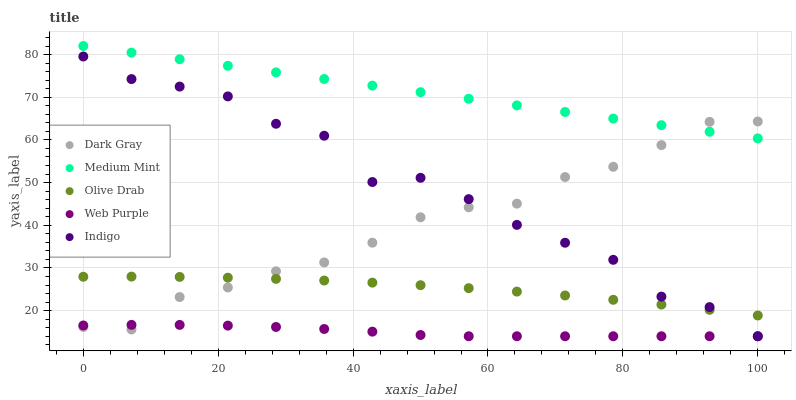Does Web Purple have the minimum area under the curve?
Answer yes or no. Yes. Does Medium Mint have the maximum area under the curve?
Answer yes or no. Yes. Does Medium Mint have the minimum area under the curve?
Answer yes or no. No. Does Web Purple have the maximum area under the curve?
Answer yes or no. No. Is Medium Mint the smoothest?
Answer yes or no. Yes. Is Indigo the roughest?
Answer yes or no. Yes. Is Web Purple the smoothest?
Answer yes or no. No. Is Web Purple the roughest?
Answer yes or no. No. Does Web Purple have the lowest value?
Answer yes or no. Yes. Does Medium Mint have the lowest value?
Answer yes or no. No. Does Medium Mint have the highest value?
Answer yes or no. Yes. Does Web Purple have the highest value?
Answer yes or no. No. Is Web Purple less than Medium Mint?
Answer yes or no. Yes. Is Olive Drab greater than Web Purple?
Answer yes or no. Yes. Does Dark Gray intersect Web Purple?
Answer yes or no. Yes. Is Dark Gray less than Web Purple?
Answer yes or no. No. Is Dark Gray greater than Web Purple?
Answer yes or no. No. Does Web Purple intersect Medium Mint?
Answer yes or no. No. 